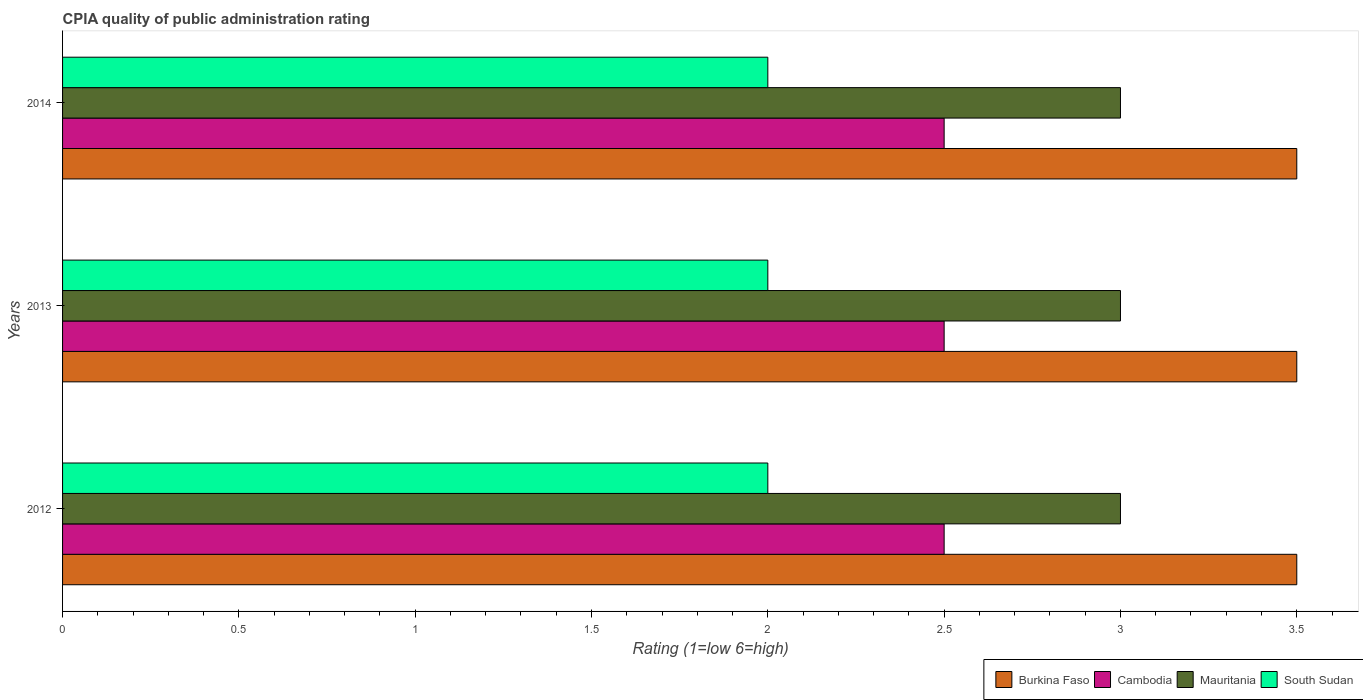How many groups of bars are there?
Provide a short and direct response. 3. Are the number of bars per tick equal to the number of legend labels?
Give a very brief answer. Yes. Are the number of bars on each tick of the Y-axis equal?
Make the answer very short. Yes. How many bars are there on the 2nd tick from the bottom?
Make the answer very short. 4. What is the label of the 3rd group of bars from the top?
Offer a terse response. 2012. In how many cases, is the number of bars for a given year not equal to the number of legend labels?
Provide a succinct answer. 0. Across all years, what is the minimum CPIA rating in Burkina Faso?
Provide a succinct answer. 3.5. What is the total CPIA rating in Cambodia in the graph?
Your answer should be very brief. 7.5. What is the difference between the CPIA rating in Mauritania in 2014 and the CPIA rating in Burkina Faso in 2012?
Your answer should be very brief. -0.5. What is the average CPIA rating in Burkina Faso per year?
Ensure brevity in your answer.  3.5. In the year 2014, what is the difference between the CPIA rating in South Sudan and CPIA rating in Burkina Faso?
Your answer should be compact. -1.5. Is the CPIA rating in South Sudan in 2012 less than that in 2014?
Offer a very short reply. No. Is the difference between the CPIA rating in South Sudan in 2012 and 2013 greater than the difference between the CPIA rating in Burkina Faso in 2012 and 2013?
Make the answer very short. No. In how many years, is the CPIA rating in South Sudan greater than the average CPIA rating in South Sudan taken over all years?
Your answer should be compact. 0. Is the sum of the CPIA rating in Burkina Faso in 2012 and 2014 greater than the maximum CPIA rating in South Sudan across all years?
Your answer should be very brief. Yes. Is it the case that in every year, the sum of the CPIA rating in Mauritania and CPIA rating in Burkina Faso is greater than the sum of CPIA rating in South Sudan and CPIA rating in Cambodia?
Your answer should be compact. No. What does the 3rd bar from the top in 2013 represents?
Provide a succinct answer. Cambodia. What does the 1st bar from the bottom in 2013 represents?
Give a very brief answer. Burkina Faso. Are all the bars in the graph horizontal?
Offer a very short reply. Yes. How many years are there in the graph?
Your answer should be compact. 3. What is the difference between two consecutive major ticks on the X-axis?
Keep it short and to the point. 0.5. How many legend labels are there?
Your response must be concise. 4. How are the legend labels stacked?
Offer a very short reply. Horizontal. What is the title of the graph?
Keep it short and to the point. CPIA quality of public administration rating. Does "Korea (Republic)" appear as one of the legend labels in the graph?
Give a very brief answer. No. What is the label or title of the Y-axis?
Provide a succinct answer. Years. What is the Rating (1=low 6=high) of Mauritania in 2012?
Make the answer very short. 3. What is the Rating (1=low 6=high) of South Sudan in 2012?
Give a very brief answer. 2. What is the Rating (1=low 6=high) in Burkina Faso in 2013?
Provide a succinct answer. 3.5. What is the Rating (1=low 6=high) in Cambodia in 2013?
Provide a short and direct response. 2.5. What is the Rating (1=low 6=high) in Mauritania in 2013?
Your response must be concise. 3. What is the Rating (1=low 6=high) in South Sudan in 2013?
Give a very brief answer. 2. What is the Rating (1=low 6=high) of Burkina Faso in 2014?
Your answer should be compact. 3.5. What is the Rating (1=low 6=high) of South Sudan in 2014?
Offer a very short reply. 2. Across all years, what is the maximum Rating (1=low 6=high) of Burkina Faso?
Your answer should be compact. 3.5. Across all years, what is the maximum Rating (1=low 6=high) in Cambodia?
Ensure brevity in your answer.  2.5. Across all years, what is the maximum Rating (1=low 6=high) of Mauritania?
Provide a succinct answer. 3. Across all years, what is the minimum Rating (1=low 6=high) of Mauritania?
Offer a very short reply. 3. What is the total Rating (1=low 6=high) in South Sudan in the graph?
Provide a succinct answer. 6. What is the difference between the Rating (1=low 6=high) in Burkina Faso in 2012 and that in 2013?
Your answer should be compact. 0. What is the difference between the Rating (1=low 6=high) in Burkina Faso in 2012 and that in 2014?
Provide a succinct answer. 0. What is the difference between the Rating (1=low 6=high) of Cambodia in 2012 and that in 2014?
Offer a terse response. 0. What is the difference between the Rating (1=low 6=high) in Mauritania in 2012 and that in 2014?
Offer a very short reply. 0. What is the difference between the Rating (1=low 6=high) in South Sudan in 2012 and that in 2014?
Offer a very short reply. 0. What is the difference between the Rating (1=low 6=high) of Mauritania in 2013 and that in 2014?
Make the answer very short. 0. What is the difference between the Rating (1=low 6=high) in South Sudan in 2013 and that in 2014?
Offer a terse response. 0. What is the difference between the Rating (1=low 6=high) of Burkina Faso in 2012 and the Rating (1=low 6=high) of South Sudan in 2013?
Ensure brevity in your answer.  1.5. What is the difference between the Rating (1=low 6=high) in Cambodia in 2012 and the Rating (1=low 6=high) in South Sudan in 2013?
Provide a short and direct response. 0.5. What is the difference between the Rating (1=low 6=high) of Mauritania in 2012 and the Rating (1=low 6=high) of South Sudan in 2013?
Make the answer very short. 1. What is the difference between the Rating (1=low 6=high) of Burkina Faso in 2012 and the Rating (1=low 6=high) of Cambodia in 2014?
Provide a short and direct response. 1. What is the difference between the Rating (1=low 6=high) of Cambodia in 2012 and the Rating (1=low 6=high) of South Sudan in 2014?
Your response must be concise. 0.5. What is the difference between the Rating (1=low 6=high) in Mauritania in 2012 and the Rating (1=low 6=high) in South Sudan in 2014?
Offer a very short reply. 1. What is the difference between the Rating (1=low 6=high) in Burkina Faso in 2013 and the Rating (1=low 6=high) in Mauritania in 2014?
Offer a terse response. 0.5. What is the difference between the Rating (1=low 6=high) in Cambodia in 2013 and the Rating (1=low 6=high) in South Sudan in 2014?
Keep it short and to the point. 0.5. What is the difference between the Rating (1=low 6=high) in Mauritania in 2013 and the Rating (1=low 6=high) in South Sudan in 2014?
Make the answer very short. 1. What is the average Rating (1=low 6=high) of Burkina Faso per year?
Make the answer very short. 3.5. What is the average Rating (1=low 6=high) of Cambodia per year?
Offer a terse response. 2.5. What is the average Rating (1=low 6=high) in Mauritania per year?
Provide a short and direct response. 3. What is the average Rating (1=low 6=high) in South Sudan per year?
Give a very brief answer. 2. In the year 2012, what is the difference between the Rating (1=low 6=high) of Burkina Faso and Rating (1=low 6=high) of Mauritania?
Keep it short and to the point. 0.5. In the year 2012, what is the difference between the Rating (1=low 6=high) in Burkina Faso and Rating (1=low 6=high) in South Sudan?
Give a very brief answer. 1.5. In the year 2012, what is the difference between the Rating (1=low 6=high) in Cambodia and Rating (1=low 6=high) in Mauritania?
Provide a succinct answer. -0.5. In the year 2013, what is the difference between the Rating (1=low 6=high) of Burkina Faso and Rating (1=low 6=high) of Mauritania?
Provide a short and direct response. 0.5. In the year 2014, what is the difference between the Rating (1=low 6=high) in Burkina Faso and Rating (1=low 6=high) in Cambodia?
Make the answer very short. 1. In the year 2014, what is the difference between the Rating (1=low 6=high) of Burkina Faso and Rating (1=low 6=high) of South Sudan?
Your answer should be compact. 1.5. In the year 2014, what is the difference between the Rating (1=low 6=high) of Mauritania and Rating (1=low 6=high) of South Sudan?
Offer a very short reply. 1. What is the ratio of the Rating (1=low 6=high) in Burkina Faso in 2012 to that in 2014?
Ensure brevity in your answer.  1. What is the ratio of the Rating (1=low 6=high) in Mauritania in 2012 to that in 2014?
Your response must be concise. 1. What is the ratio of the Rating (1=low 6=high) in Burkina Faso in 2013 to that in 2014?
Your answer should be compact. 1. What is the difference between the highest and the second highest Rating (1=low 6=high) in Burkina Faso?
Provide a succinct answer. 0. What is the difference between the highest and the second highest Rating (1=low 6=high) of Mauritania?
Your answer should be very brief. 0. What is the difference between the highest and the second highest Rating (1=low 6=high) in South Sudan?
Offer a very short reply. 0. What is the difference between the highest and the lowest Rating (1=low 6=high) of Cambodia?
Your answer should be compact. 0. What is the difference between the highest and the lowest Rating (1=low 6=high) in South Sudan?
Provide a succinct answer. 0. 